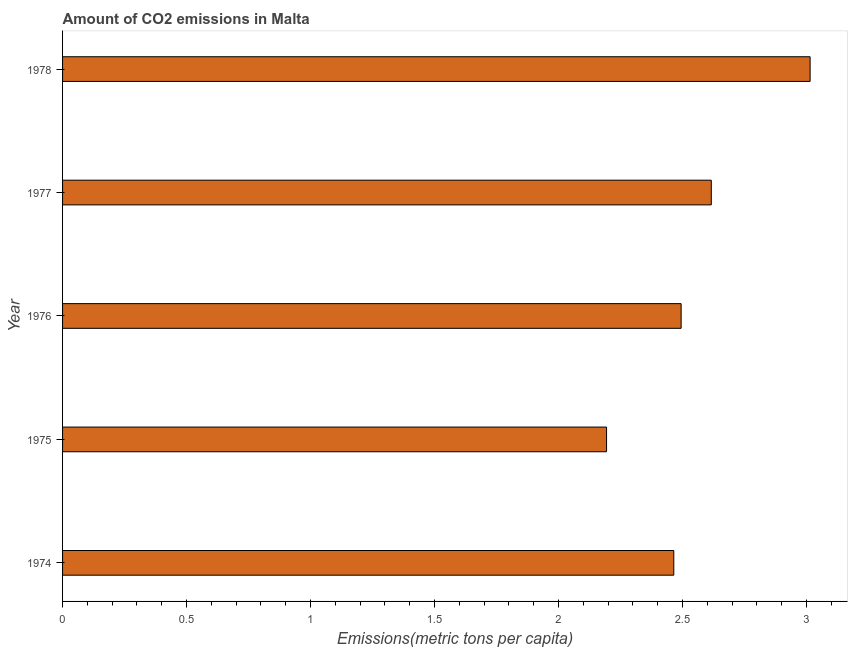What is the title of the graph?
Make the answer very short. Amount of CO2 emissions in Malta. What is the label or title of the X-axis?
Make the answer very short. Emissions(metric tons per capita). What is the label or title of the Y-axis?
Provide a short and direct response. Year. What is the amount of co2 emissions in 1975?
Your response must be concise. 2.19. Across all years, what is the maximum amount of co2 emissions?
Make the answer very short. 3.01. Across all years, what is the minimum amount of co2 emissions?
Keep it short and to the point. 2.19. In which year was the amount of co2 emissions maximum?
Offer a very short reply. 1978. In which year was the amount of co2 emissions minimum?
Provide a succinct answer. 1975. What is the sum of the amount of co2 emissions?
Give a very brief answer. 12.78. What is the difference between the amount of co2 emissions in 1975 and 1978?
Offer a very short reply. -0.82. What is the average amount of co2 emissions per year?
Ensure brevity in your answer.  2.56. What is the median amount of co2 emissions?
Make the answer very short. 2.49. Do a majority of the years between 1977 and 1978 (inclusive) have amount of co2 emissions greater than 0.6 metric tons per capita?
Ensure brevity in your answer.  Yes. What is the ratio of the amount of co2 emissions in 1977 to that in 1978?
Give a very brief answer. 0.87. Is the difference between the amount of co2 emissions in 1975 and 1976 greater than the difference between any two years?
Offer a terse response. No. What is the difference between the highest and the second highest amount of co2 emissions?
Offer a very short reply. 0.4. What is the difference between the highest and the lowest amount of co2 emissions?
Make the answer very short. 0.82. What is the difference between two consecutive major ticks on the X-axis?
Offer a terse response. 0.5. Are the values on the major ticks of X-axis written in scientific E-notation?
Your answer should be compact. No. What is the Emissions(metric tons per capita) in 1974?
Your response must be concise. 2.46. What is the Emissions(metric tons per capita) in 1975?
Ensure brevity in your answer.  2.19. What is the Emissions(metric tons per capita) of 1976?
Keep it short and to the point. 2.49. What is the Emissions(metric tons per capita) of 1977?
Make the answer very short. 2.62. What is the Emissions(metric tons per capita) of 1978?
Your answer should be compact. 3.01. What is the difference between the Emissions(metric tons per capita) in 1974 and 1975?
Your answer should be very brief. 0.27. What is the difference between the Emissions(metric tons per capita) in 1974 and 1976?
Give a very brief answer. -0.03. What is the difference between the Emissions(metric tons per capita) in 1974 and 1977?
Your answer should be compact. -0.15. What is the difference between the Emissions(metric tons per capita) in 1974 and 1978?
Make the answer very short. -0.55. What is the difference between the Emissions(metric tons per capita) in 1975 and 1976?
Provide a succinct answer. -0.3. What is the difference between the Emissions(metric tons per capita) in 1975 and 1977?
Your response must be concise. -0.42. What is the difference between the Emissions(metric tons per capita) in 1975 and 1978?
Your response must be concise. -0.82. What is the difference between the Emissions(metric tons per capita) in 1976 and 1977?
Offer a very short reply. -0.12. What is the difference between the Emissions(metric tons per capita) in 1976 and 1978?
Provide a short and direct response. -0.52. What is the difference between the Emissions(metric tons per capita) in 1977 and 1978?
Provide a succinct answer. -0.4. What is the ratio of the Emissions(metric tons per capita) in 1974 to that in 1975?
Make the answer very short. 1.12. What is the ratio of the Emissions(metric tons per capita) in 1974 to that in 1976?
Ensure brevity in your answer.  0.99. What is the ratio of the Emissions(metric tons per capita) in 1974 to that in 1977?
Provide a short and direct response. 0.94. What is the ratio of the Emissions(metric tons per capita) in 1974 to that in 1978?
Your response must be concise. 0.82. What is the ratio of the Emissions(metric tons per capita) in 1975 to that in 1976?
Offer a terse response. 0.88. What is the ratio of the Emissions(metric tons per capita) in 1975 to that in 1977?
Provide a succinct answer. 0.84. What is the ratio of the Emissions(metric tons per capita) in 1975 to that in 1978?
Offer a very short reply. 0.73. What is the ratio of the Emissions(metric tons per capita) in 1976 to that in 1977?
Offer a terse response. 0.95. What is the ratio of the Emissions(metric tons per capita) in 1976 to that in 1978?
Your answer should be compact. 0.83. What is the ratio of the Emissions(metric tons per capita) in 1977 to that in 1978?
Keep it short and to the point. 0.87. 